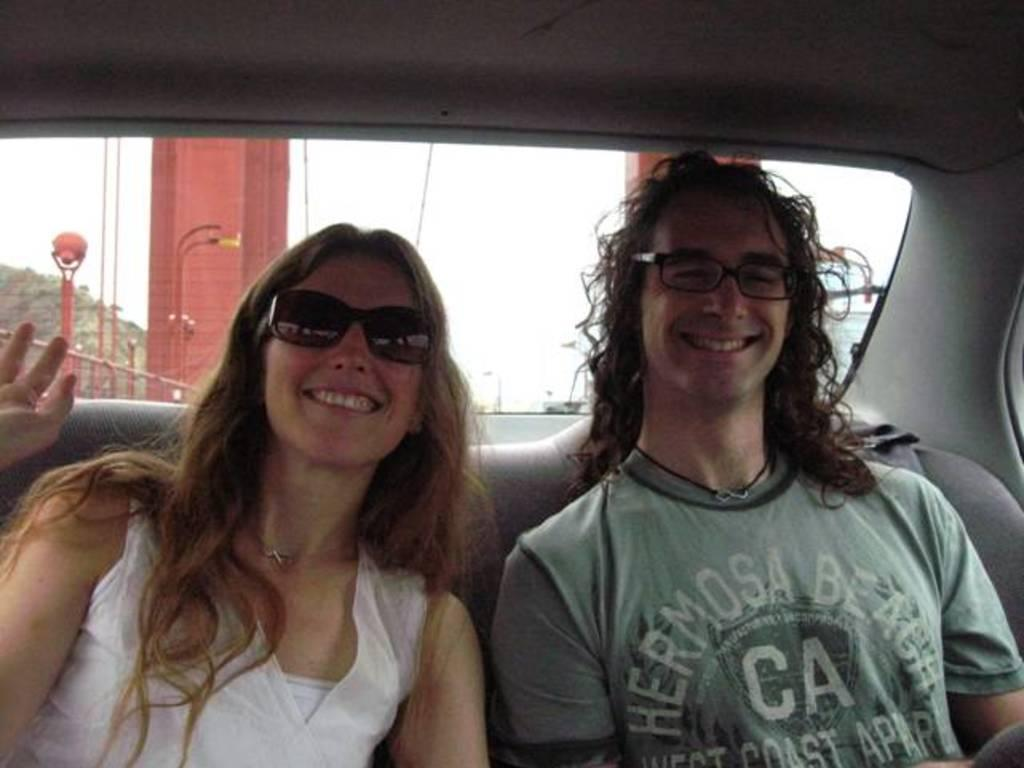How many people are in the image? There are two people in the image. What are the two people doing in the image? The two people are sitting. What type of eyewear are the people wearing in the image? Both people are wearing goggles and spectacles. What is the facial expression of the people in the image? Both people are smiling. What time of day is it in the image, and how does the dock contribute to the scene? There is no dock present in the image, and the time of day cannot be determined from the provided facts. 